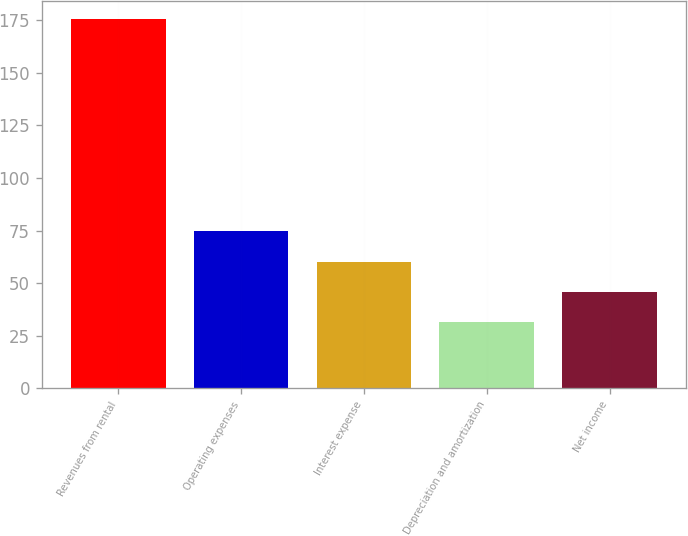Convert chart to OTSL. <chart><loc_0><loc_0><loc_500><loc_500><bar_chart><fcel>Revenues from rental<fcel>Operating expenses<fcel>Interest expense<fcel>Depreciation and amortization<fcel>Net income<nl><fcel>175.6<fcel>74.66<fcel>60.24<fcel>31.4<fcel>45.82<nl></chart> 